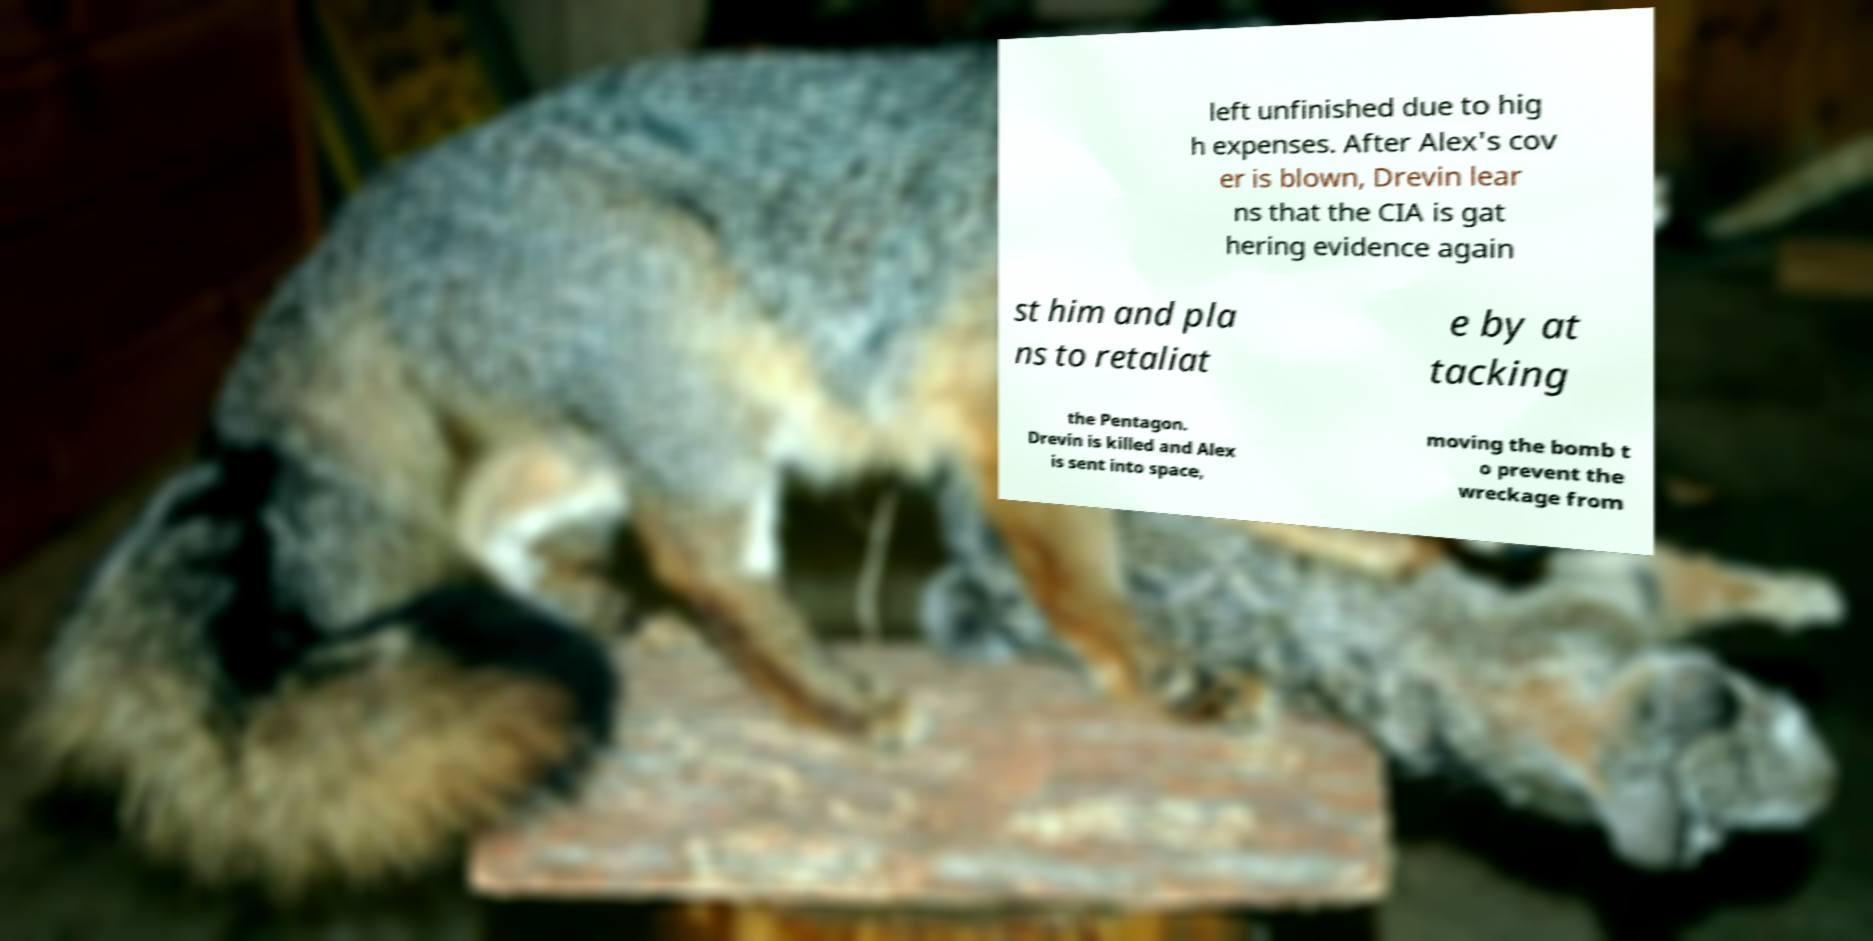For documentation purposes, I need the text within this image transcribed. Could you provide that? left unfinished due to hig h expenses. After Alex's cov er is blown, Drevin lear ns that the CIA is gat hering evidence again st him and pla ns to retaliat e by at tacking the Pentagon. Drevin is killed and Alex is sent into space, moving the bomb t o prevent the wreckage from 